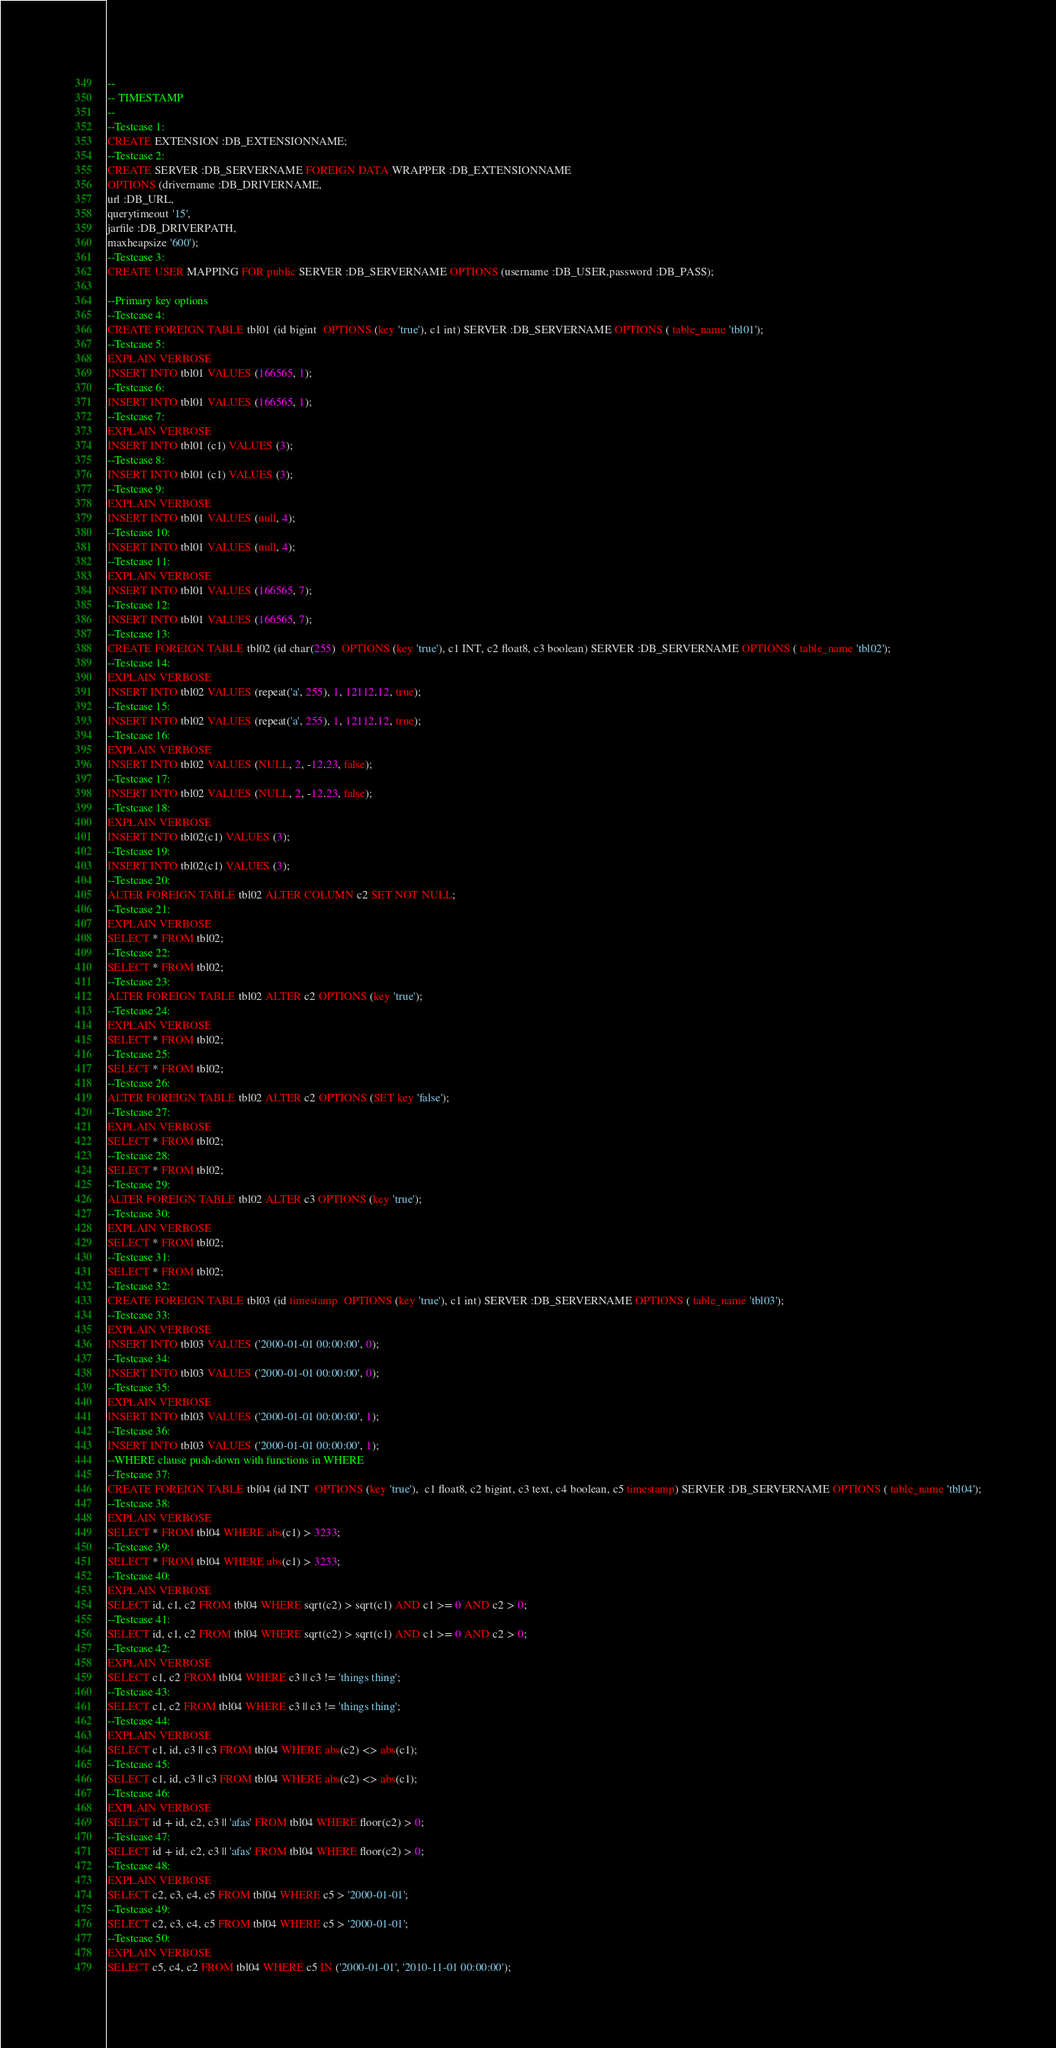<code> <loc_0><loc_0><loc_500><loc_500><_SQL_>--
-- TIMESTAMP
--
--Testcase 1:
CREATE EXTENSION :DB_EXTENSIONNAME;
--Testcase 2:
CREATE SERVER :DB_SERVERNAME FOREIGN DATA WRAPPER :DB_EXTENSIONNAME
OPTIONS (drivername :DB_DRIVERNAME,
url :DB_URL,
querytimeout '15',
jarfile :DB_DRIVERPATH,
maxheapsize '600');
--Testcase 3:
CREATE USER MAPPING FOR public SERVER :DB_SERVERNAME OPTIONS (username :DB_USER,password :DB_PASS);  

--Primary key options
--Testcase 4:
CREATE FOREIGN TABLE tbl01 (id bigint  OPTIONS (key 'true'), c1 int) SERVER :DB_SERVERNAME OPTIONS ( table_name 'tbl01');
--Testcase 5:
EXPLAIN VERBOSE
INSERT INTO tbl01 VALUES (166565, 1);
--Testcase 6:
INSERT INTO tbl01 VALUES (166565, 1);
--Testcase 7:
EXPLAIN VERBOSE
INSERT INTO tbl01 (c1) VALUES (3);
--Testcase 8:
INSERT INTO tbl01 (c1) VALUES (3);
--Testcase 9:
EXPLAIN VERBOSE
INSERT INTO tbl01 VALUES (null, 4);
--Testcase 10:
INSERT INTO tbl01 VALUES (null, 4);
--Testcase 11:
EXPLAIN VERBOSE
INSERT INTO tbl01 VALUES (166565, 7);
--Testcase 12:
INSERT INTO tbl01 VALUES (166565, 7);
--Testcase 13:
CREATE FOREIGN TABLE tbl02 (id char(255)  OPTIONS (key 'true'), c1 INT, c2 float8, c3 boolean) SERVER :DB_SERVERNAME OPTIONS ( table_name 'tbl02');
--Testcase 14:
EXPLAIN VERBOSE
INSERT INTO tbl02 VALUES (repeat('a', 255), 1, 12112.12, true);
--Testcase 15:
INSERT INTO tbl02 VALUES (repeat('a', 255), 1, 12112.12, true);
--Testcase 16:
EXPLAIN VERBOSE
INSERT INTO tbl02 VALUES (NULL, 2, -12.23, false);
--Testcase 17:
INSERT INTO tbl02 VALUES (NULL, 2, -12.23, false);
--Testcase 18:
EXPLAIN VERBOSE
INSERT INTO tbl02(c1) VALUES (3);
--Testcase 19:
INSERT INTO tbl02(c1) VALUES (3);
--Testcase 20:
ALTER FOREIGN TABLE tbl02 ALTER COLUMN c2 SET NOT NULL;
--Testcase 21:
EXPLAIN VERBOSE
SELECT * FROM tbl02;
--Testcase 22:
SELECT * FROM tbl02;
--Testcase 23:
ALTER FOREIGN TABLE tbl02 ALTER c2 OPTIONS (key 'true');
--Testcase 24:
EXPLAIN VERBOSE
SELECT * FROM tbl02;
--Testcase 25:
SELECT * FROM tbl02;
--Testcase 26:
ALTER FOREIGN TABLE tbl02 ALTER c2 OPTIONS (SET key 'false');
--Testcase 27:
EXPLAIN VERBOSE
SELECT * FROM tbl02;
--Testcase 28:
SELECT * FROM tbl02;
--Testcase 29:
ALTER FOREIGN TABLE tbl02 ALTER c3 OPTIONS (key 'true');
--Testcase 30:
EXPLAIN VERBOSE
SELECT * FROM tbl02;
--Testcase 31:
SELECT * FROM tbl02;
--Testcase 32:
CREATE FOREIGN TABLE tbl03 (id timestamp  OPTIONS (key 'true'), c1 int) SERVER :DB_SERVERNAME OPTIONS ( table_name 'tbl03');
--Testcase 33:
EXPLAIN VERBOSE
INSERT INTO tbl03 VALUES ('2000-01-01 00:00:00', 0);
--Testcase 34:
INSERT INTO tbl03 VALUES ('2000-01-01 00:00:00', 0);
--Testcase 35:
EXPLAIN VERBOSE
INSERT INTO tbl03 VALUES ('2000-01-01 00:00:00', 1);
--Testcase 36:
INSERT INTO tbl03 VALUES ('2000-01-01 00:00:00', 1);
--WHERE clause push-down with functions in WHERE
--Testcase 37:
CREATE FOREIGN TABLE tbl04 (id INT  OPTIONS (key 'true'),  c1 float8, c2 bigint, c3 text, c4 boolean, c5 timestamp) SERVER :DB_SERVERNAME OPTIONS ( table_name 'tbl04');
--Testcase 38:
EXPLAIN VERBOSE
SELECT * FROM tbl04 WHERE abs(c1) > 3233;
--Testcase 39:
SELECT * FROM tbl04 WHERE abs(c1) > 3233;
--Testcase 40:
EXPLAIN VERBOSE
SELECT id, c1, c2 FROM tbl04 WHERE sqrt(c2) > sqrt(c1) AND c1 >= 0 AND c2 > 0;
--Testcase 41:
SELECT id, c1, c2 FROM tbl04 WHERE sqrt(c2) > sqrt(c1) AND c1 >= 0 AND c2 > 0;
--Testcase 42:
EXPLAIN VERBOSE
SELECT c1, c2 FROM tbl04 WHERE c3 || c3 != 'things thing';
--Testcase 43:
SELECT c1, c2 FROM tbl04 WHERE c3 || c3 != 'things thing';
--Testcase 44:
EXPLAIN VERBOSE
SELECT c1, id, c3 || c3 FROM tbl04 WHERE abs(c2) <> abs(c1);
--Testcase 45:
SELECT c1, id, c3 || c3 FROM tbl04 WHERE abs(c2) <> abs(c1);
--Testcase 46:
EXPLAIN VERBOSE
SELECT id + id, c2, c3 || 'afas' FROM tbl04 WHERE floor(c2) > 0;
--Testcase 47:
SELECT id + id, c2, c3 || 'afas' FROM tbl04 WHERE floor(c2) > 0;
--Testcase 48:
EXPLAIN VERBOSE
SELECT c2, c3, c4, c5 FROM tbl04 WHERE c5 > '2000-01-01';
--Testcase 49:
SELECT c2, c3, c4, c5 FROM tbl04 WHERE c5 > '2000-01-01';
--Testcase 50:
EXPLAIN VERBOSE
SELECT c5, c4, c2 FROM tbl04 WHERE c5 IN ('2000-01-01', '2010-11-01 00:00:00');</code> 